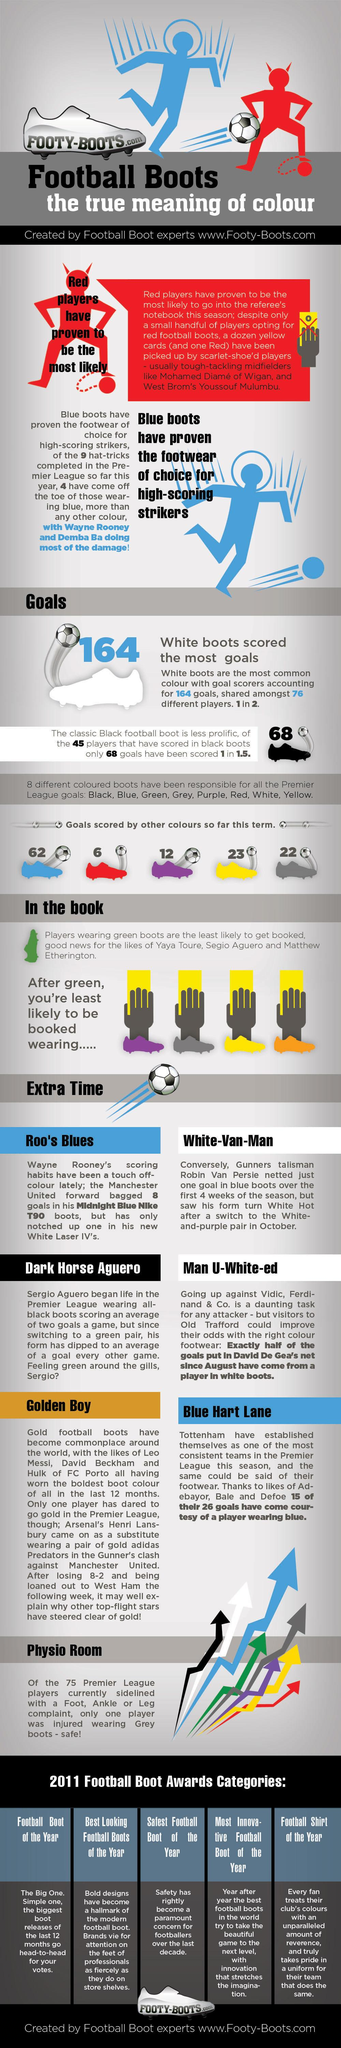Indicate a few pertinent items in this graphic. It is commonly believed that blue is the most preferred shoe color among strikers, followed by red and yellow. However, there is limited evidence to support this claim, and further research is needed to confirm these findings. The color of football boots that was the least likely to receive a yellow card was green. In the Premier League, there have been 23 goals scored by players wearing yellow boots. 